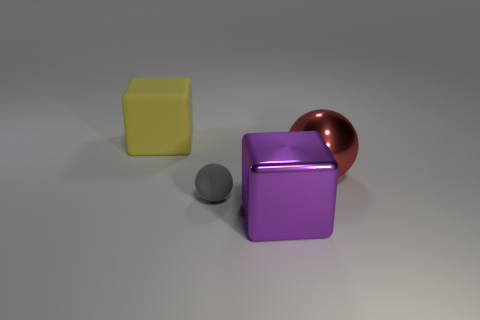What number of tiny objects have the same color as the big metallic sphere? 0 